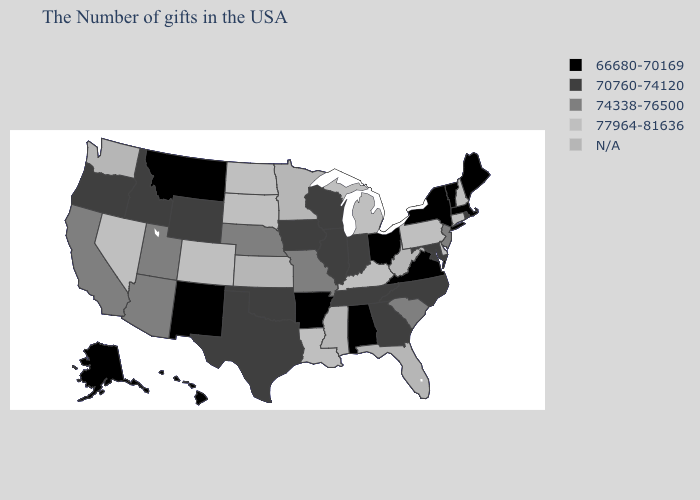Name the states that have a value in the range 74338-76500?
Give a very brief answer. New Jersey, South Carolina, Missouri, Nebraska, Utah, Arizona, California. Name the states that have a value in the range 74338-76500?
Quick response, please. New Jersey, South Carolina, Missouri, Nebraska, Utah, Arizona, California. Does the first symbol in the legend represent the smallest category?
Keep it brief. Yes. Among the states that border Missouri , which have the highest value?
Concise answer only. Kentucky. Does the map have missing data?
Be succinct. Yes. Does Connecticut have the lowest value in the USA?
Write a very short answer. No. Does North Dakota have the highest value in the USA?
Quick response, please. Yes. Which states have the highest value in the USA?
Write a very short answer. New Hampshire, Connecticut, Delaware, Pennsylvania, Michigan, Kentucky, Louisiana, South Dakota, North Dakota, Colorado, Nevada. Does New York have the highest value in the USA?
Write a very short answer. No. Name the states that have a value in the range 70760-74120?
Short answer required. Rhode Island, Maryland, North Carolina, Georgia, Indiana, Tennessee, Wisconsin, Illinois, Iowa, Oklahoma, Texas, Wyoming, Idaho, Oregon. What is the value of Maryland?
Answer briefly. 70760-74120. Name the states that have a value in the range 66680-70169?
Short answer required. Maine, Massachusetts, Vermont, New York, Virginia, Ohio, Alabama, Arkansas, New Mexico, Montana, Alaska, Hawaii. Name the states that have a value in the range 74338-76500?
Keep it brief. New Jersey, South Carolina, Missouri, Nebraska, Utah, Arizona, California. Name the states that have a value in the range 74338-76500?
Be succinct. New Jersey, South Carolina, Missouri, Nebraska, Utah, Arizona, California. Does the first symbol in the legend represent the smallest category?
Answer briefly. Yes. 